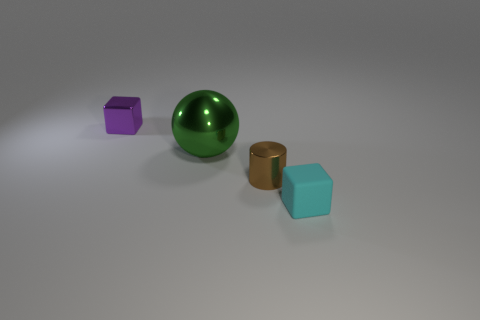What is the size of the purple shiny thing that is the same shape as the cyan thing?
Offer a very short reply. Small. How many objects are either small metallic blocks behind the small shiny cylinder or cubes on the right side of the purple object?
Your response must be concise. 2. What shape is the large object in front of the cube that is behind the tiny brown shiny cylinder?
Provide a short and direct response. Sphere. Is there anything else of the same color as the big metallic ball?
Make the answer very short. No. Is there any other thing that is the same size as the cyan object?
Your answer should be very brief. Yes. What number of things are small brown things or large blue rubber cylinders?
Offer a terse response. 1. Is there a purple block that has the same size as the green ball?
Keep it short and to the point. No. The rubber object is what shape?
Your answer should be very brief. Cube. Are there more small brown cylinders to the left of the small cylinder than shiny cylinders that are behind the tiny purple cube?
Provide a short and direct response. No. Does the small shiny thing that is left of the green thing have the same color as the tiny metal thing right of the small purple shiny cube?
Provide a succinct answer. No. 